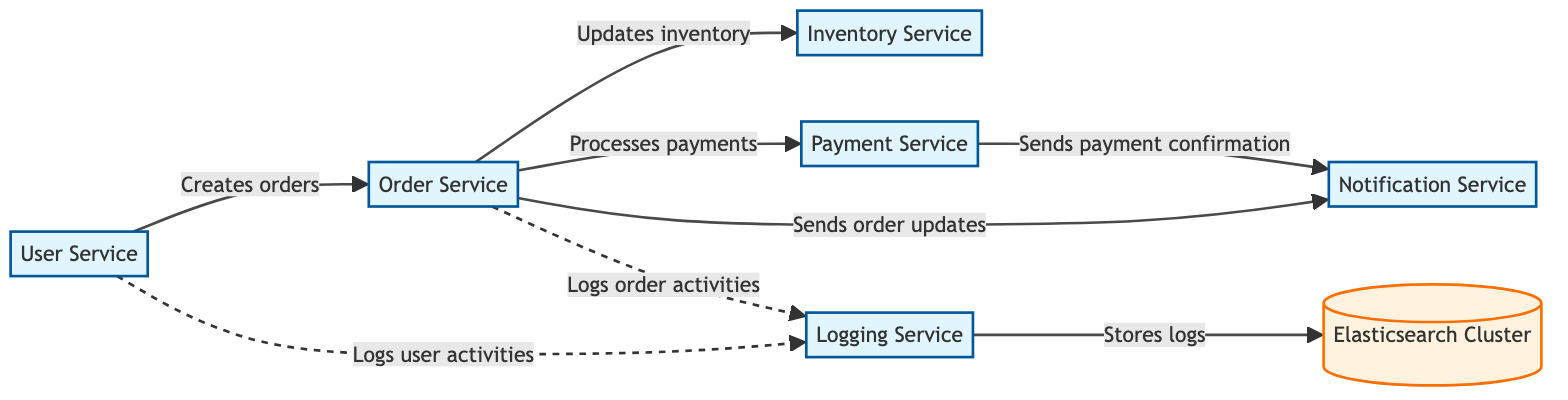What is the number of microservices in the diagram? The diagram lists six distinct services labeled as microservices: User Service, Order Service, Inventory Service, Payment Service, Notification Service, and Logging Service. Therefore, the total number of microservices is six.
Answer: 6 Which microservice handles user authentication? The User Service is described as handling user authentication, profile management, and user-related data. This indicates that it is responsible for user authentication tasks.
Answer: User Service What relationship exists between Order Service and Inventory Service? The relationship is indicated by the edge labeled "Updates inventory," which specifies that the Order Service updates inventory levels in the Inventory Service.
Answer: Updates inventory How many edges are connected to the Payment Service? In the diagram, the Payment Service has two outgoing edges: one to the Notification Service indicating payment confirmation and another from the Order Service indicating processes payments. Therefore, there are two edges connected to the Payment Service.
Answer: 2 Which service logs user activities? According to the diagram, the User Service logs user activities and sends these logs to the Logging Service, as indicated by the dashed arrow labeled "Logs user activities."
Answer: Logging Service What type of service is the Elasticsearch Cluster? The Elasticsearch Cluster is categorized as a database, as identified in the diagram where it is labeled accordingly.
Answer: Database What service is responsible for sending notifications for payment confirmations? The Payment Service triggers notifications specifically for payment confirmations, as described by the edge labeled "Sends payment confirmation."
Answer: Notification Service Which service interacts with the Logging Service for logging order activities? The Order Service is responsible for logging order activities, sending these logs to the Logging Service, as depicted by the dashed arrow labeled "Logs order activities."
Answer: Order Service How many nodes are there in total in this diagram? There are seven nodes listed in the diagram: six microservices and one database (Elasticsearch Cluster). Thus, the total number of nodes is seven.
Answer: 7 